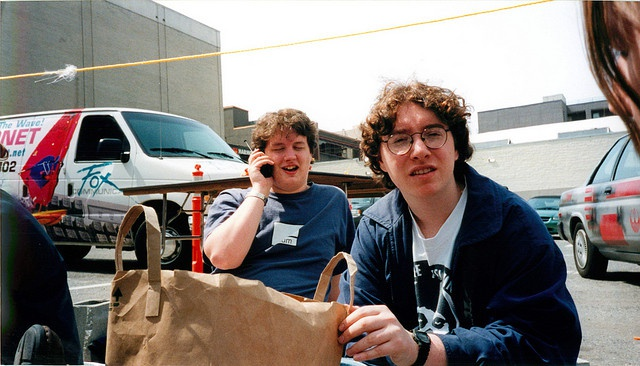Describe the objects in this image and their specific colors. I can see people in white, black, brown, and darkgray tones, car in white, black, lightgray, darkgray, and gray tones, people in white, black, navy, lightgray, and brown tones, people in white, black, gray, purple, and navy tones, and car in white, darkgray, black, gray, and lightgray tones in this image. 